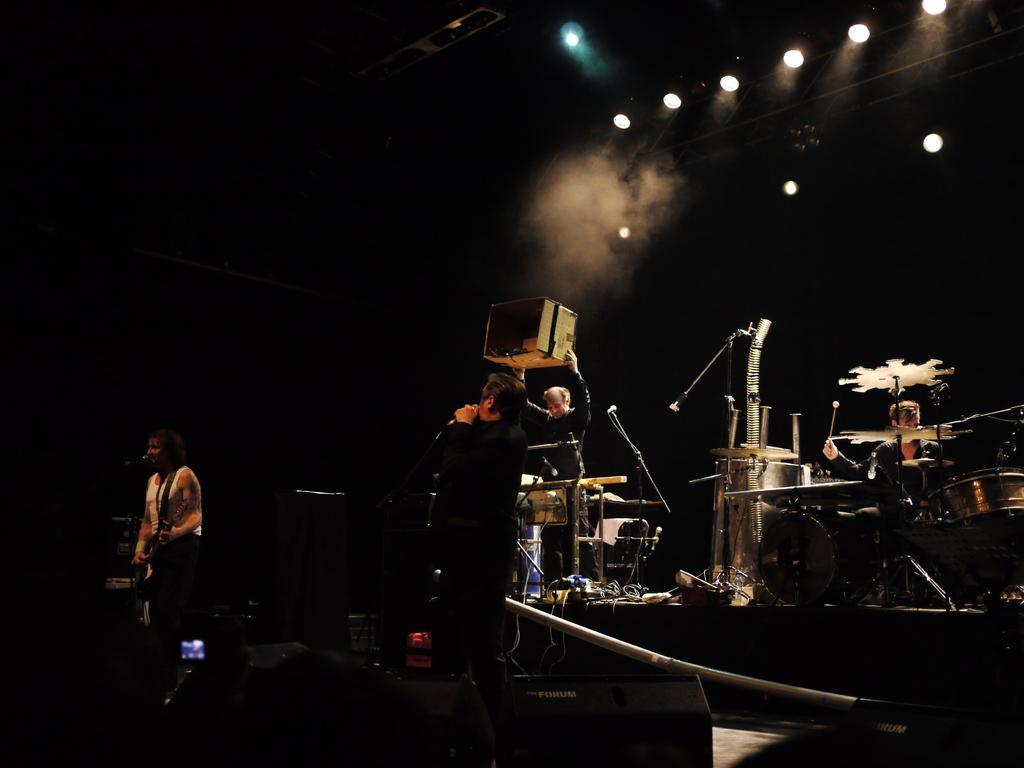In one or two sentences, can you explain what this image depicts? The picture is taken on the stage where there are people performing and one person is wearing black dress in the centre and at the right corner of the picture one person is playing a drums and beside him there is one person standing and holding a box and at the right corner of the picture one person in white shirt is playing a guitar and behind them there is smoke and some lights. 